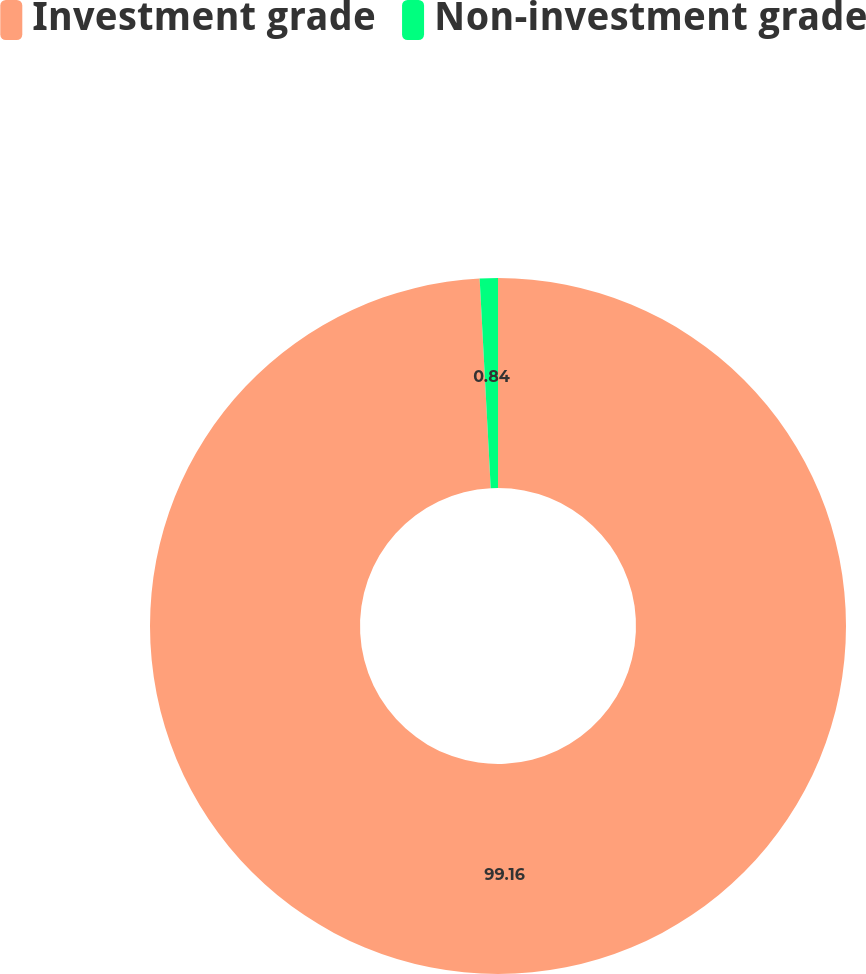Convert chart to OTSL. <chart><loc_0><loc_0><loc_500><loc_500><pie_chart><fcel>Investment grade<fcel>Non-investment grade<nl><fcel>99.16%<fcel>0.84%<nl></chart> 